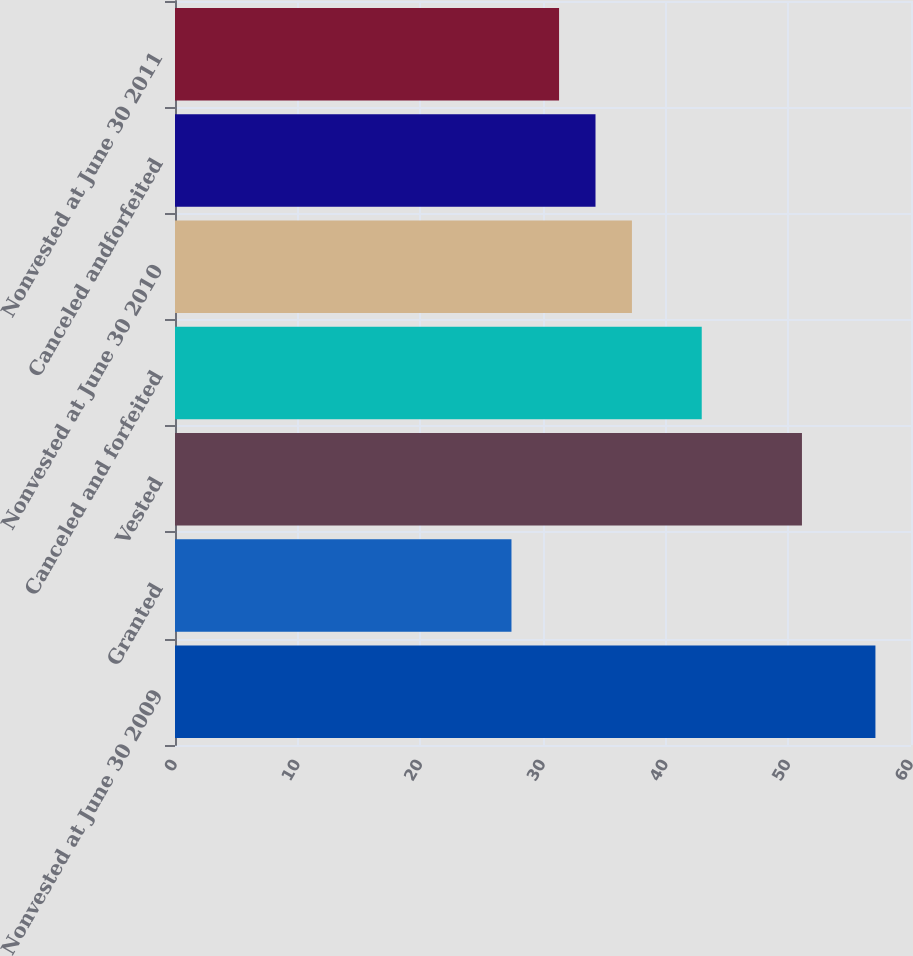Convert chart. <chart><loc_0><loc_0><loc_500><loc_500><bar_chart><fcel>Nonvested at June 30 2009<fcel>Granted<fcel>Vested<fcel>Canceled and forfeited<fcel>Nonvested at June 30 2010<fcel>Canceled andforfeited<fcel>Nonvested at June 30 2011<nl><fcel>57.1<fcel>27.43<fcel>51.11<fcel>42.94<fcel>37.25<fcel>34.28<fcel>31.31<nl></chart> 